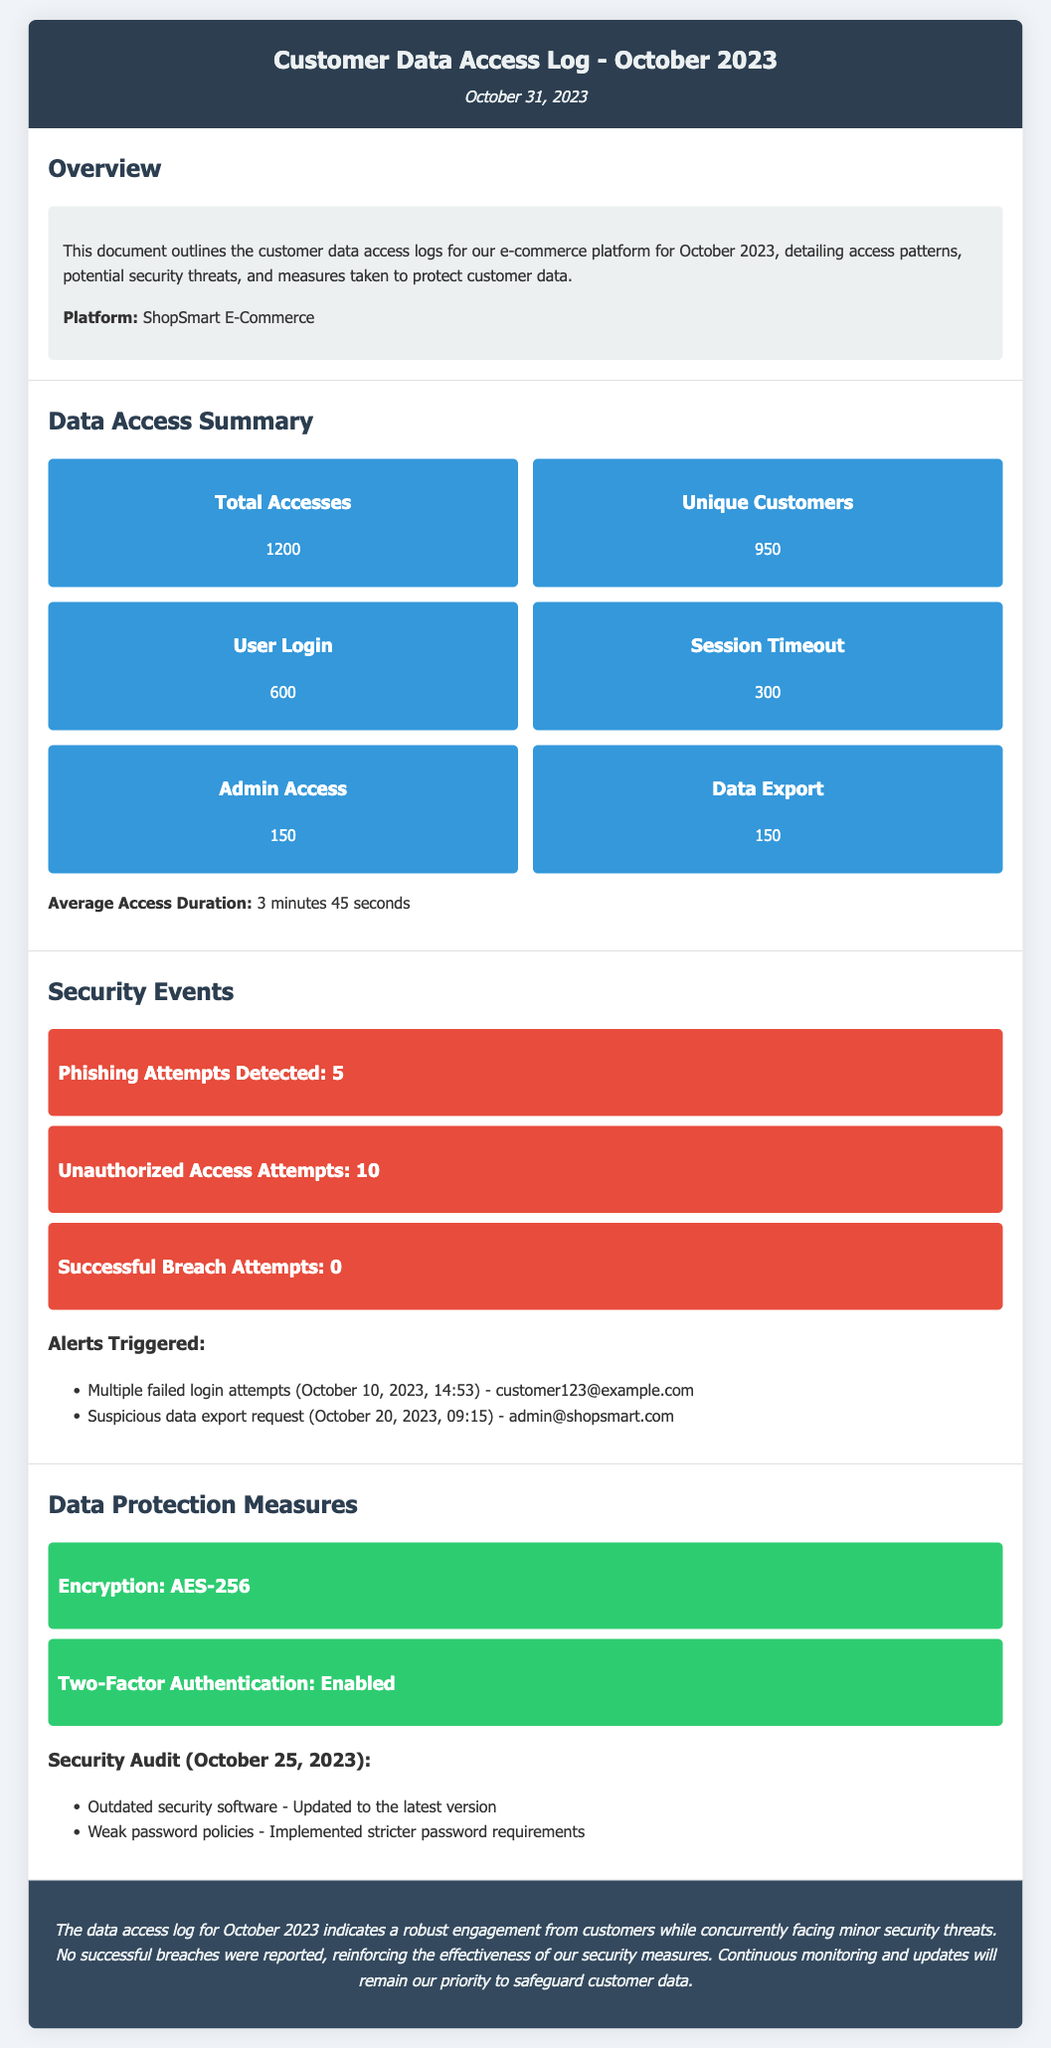What is the total number of accesses? The total number of accesses is reported directly in the summary section of the document.
Answer: 1200 How many unique customers accessed the platform? The number of unique customers is specified in the document's summary section.
Answer: 950 What was the average access duration? The average access duration is provided in the data access summary.
Answer: 3 minutes 45 seconds How many phishing attempts were detected? The document lists the number of phishing attempts in the security events section.
Answer: 5 What security measure is mentioned as enabled? The document states two-factor authentication is enabled as one of the protection measures.
Answer: Enabled What date was the security audit conducted? The document indicates the date of the security audit in the data protection measures section.
Answer: October 25, 2023 How many unauthorized access attempts were reported? The number of unauthorized access attempts is mentioned in the security events section.
Answer: 10 What type of encryption is used? The specific type of encryption employed is detailed in the data protection measures section of the document.
Answer: AES-256 What was the result of successful breach attempts? The document summarizes the successful breach attempts under security events.
Answer: 0 